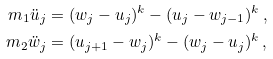<formula> <loc_0><loc_0><loc_500><loc_500>m _ { 1 } \ddot { u } _ { j } & = ( w _ { j } - u _ { j } ) ^ { k } - ( u _ { j } - w _ { j - 1 } ) ^ { k } \, , \\ m _ { 2 } \ddot { w } _ { j } & = ( u _ { j + 1 } - w _ { j } ) ^ { k } - ( w _ { j } - u _ { j } ) ^ { k } \, ,</formula> 